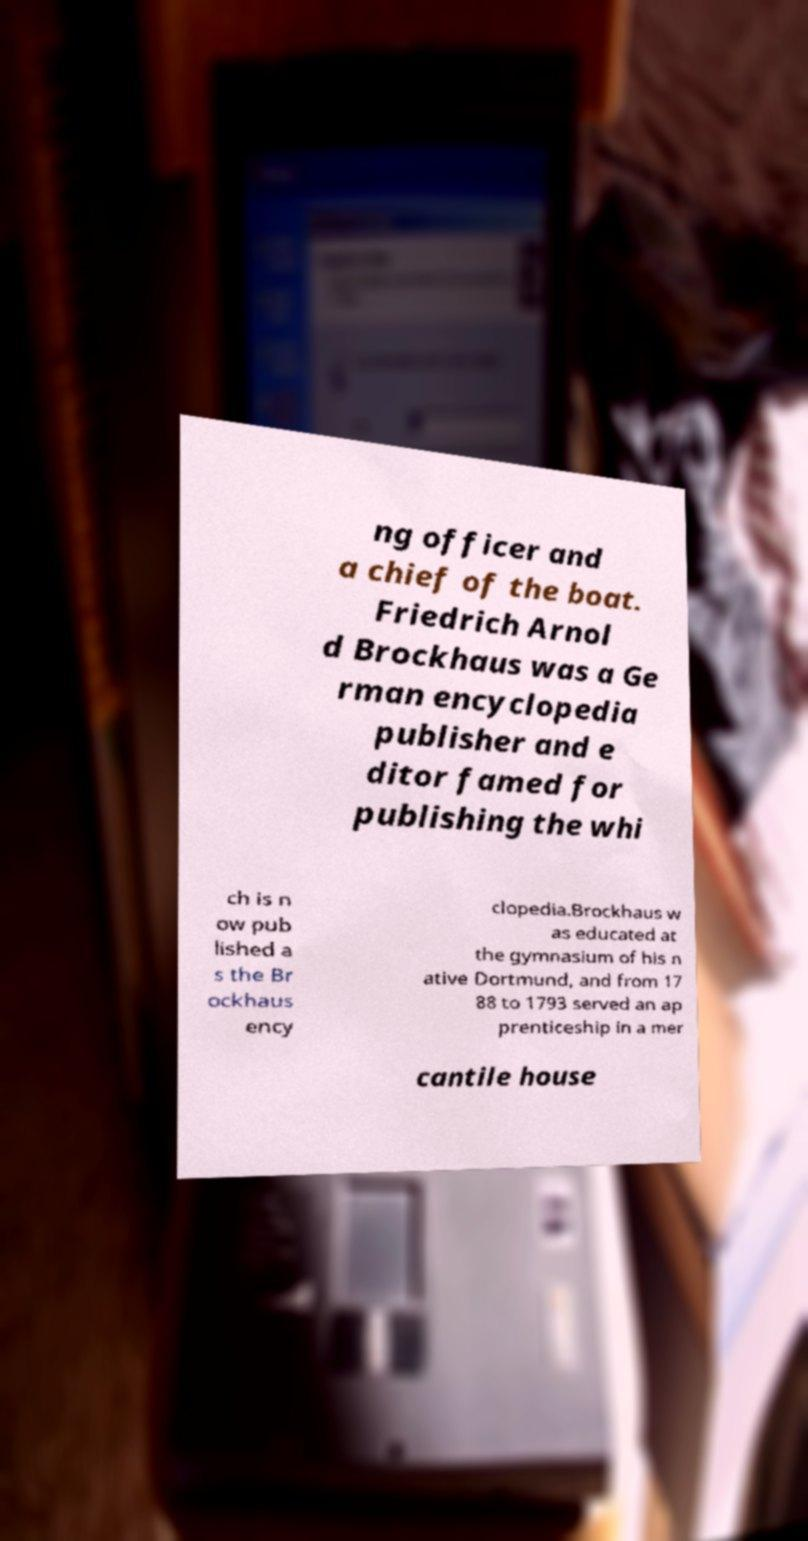Can you accurately transcribe the text from the provided image for me? ng officer and a chief of the boat. Friedrich Arnol d Brockhaus was a Ge rman encyclopedia publisher and e ditor famed for publishing the whi ch is n ow pub lished a s the Br ockhaus ency clopedia.Brockhaus w as educated at the gymnasium of his n ative Dortmund, and from 17 88 to 1793 served an ap prenticeship in a mer cantile house 